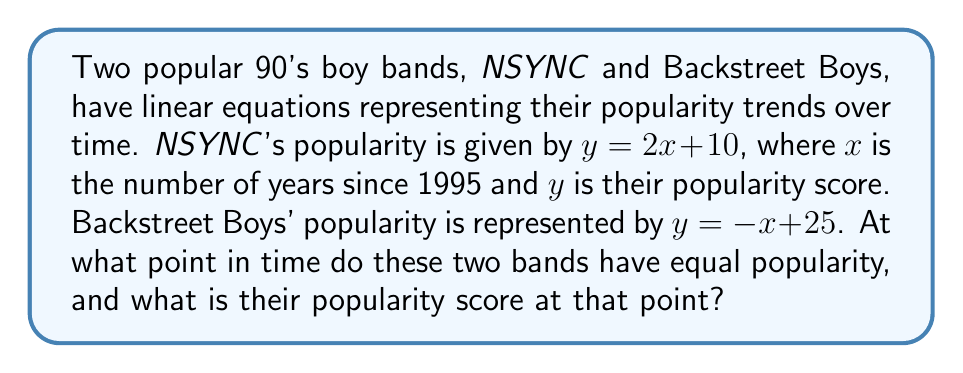Solve this math problem. To find the intersection point of the two bands' popularity trends, we need to solve the system of linear equations:

1) *NSYNC: $y = 2x + 10$
2) Backstreet Boys: $y = -x + 25$

At the intersection point, the $y$ values (popularity scores) are equal. So we can set the equations equal to each other:

$$2x + 10 = -x + 25$$

Now, let's solve for $x$:

$$2x + 10 = -x + 25$$
$$3x = 15$$
$$x = 5$$

This means the bands have equal popularity 5 years after 1995, which is the year 2000.

To find the popularity score at this point, we can substitute $x = 5$ into either equation. Let's use *NSYNC's equation:

$$y = 2(5) + 10 = 20$$

Therefore, the intersection point is (5, 20), meaning in the year 2000, both bands had a popularity score of 20.
Answer: (5, 20) 